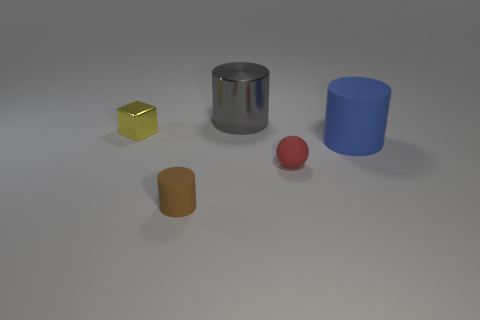Subtract all large cylinders. How many cylinders are left? 1 Subtract all blue cylinders. How many cylinders are left? 2 Subtract 1 cylinders. How many cylinders are left? 2 Add 3 blue things. How many objects exist? 8 Subtract all spheres. How many objects are left? 4 Subtract all big rubber objects. Subtract all large gray things. How many objects are left? 3 Add 3 blue matte cylinders. How many blue matte cylinders are left? 4 Add 1 large gray rubber spheres. How many large gray rubber spheres exist? 1 Subtract 0 red blocks. How many objects are left? 5 Subtract all yellow cylinders. Subtract all red blocks. How many cylinders are left? 3 